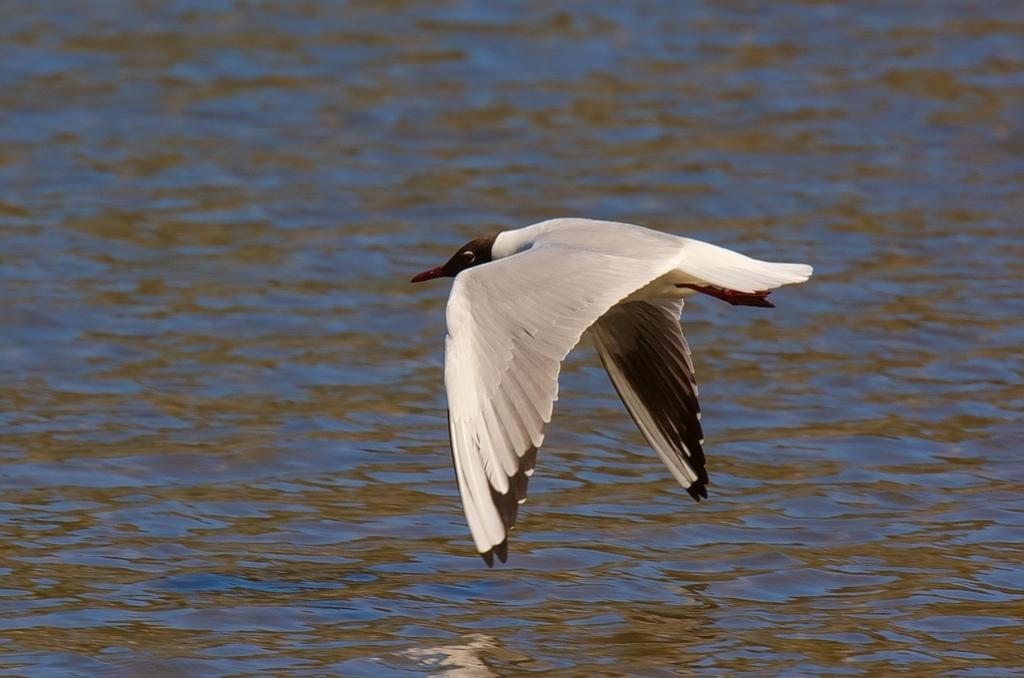Please provide a concise description of this image. In this image, we can see a bird is flying in the air. Background we can see the water all over the image. 